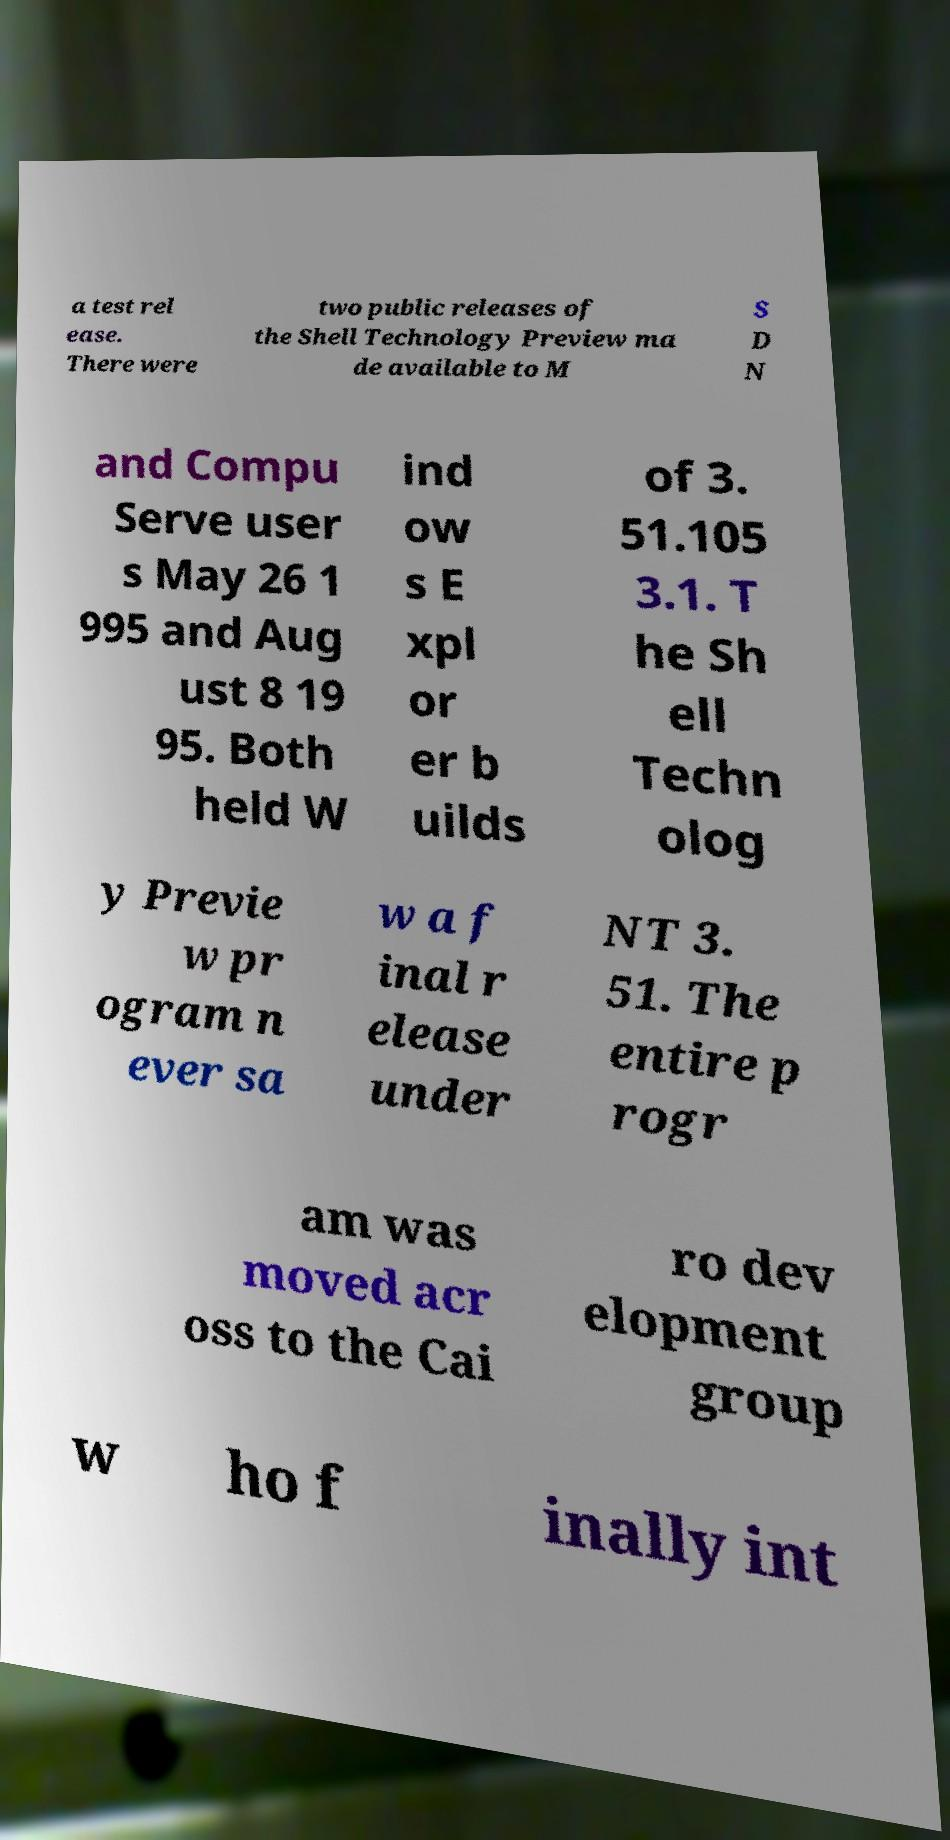Could you extract and type out the text from this image? a test rel ease. There were two public releases of the Shell Technology Preview ma de available to M S D N and Compu Serve user s May 26 1 995 and Aug ust 8 19 95. Both held W ind ow s E xpl or er b uilds of 3. 51.105 3.1. T he Sh ell Techn olog y Previe w pr ogram n ever sa w a f inal r elease under NT 3. 51. The entire p rogr am was moved acr oss to the Cai ro dev elopment group w ho f inally int 